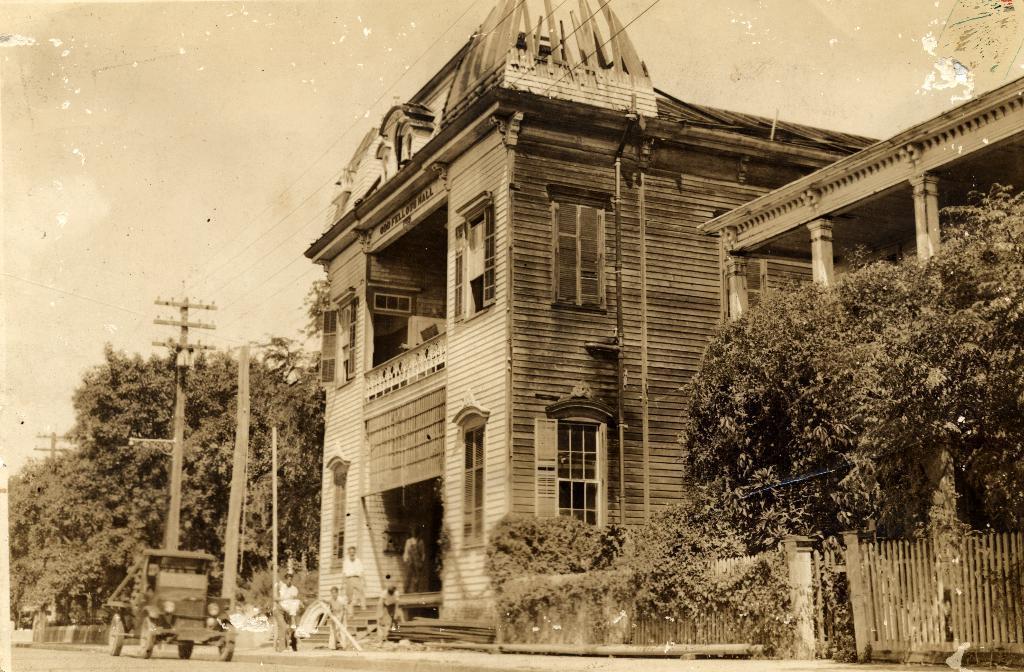Describe this image in one or two sentences. In this image there is the sky towards the top of the image, there are buildings towards the right of the image, there are windows, there is a wall, there are pillars, there is a wooden fence towards the right of the image, there are trees towards the right of the image, there are trees towards the left of the image, there are poles, there are wires towards the top of the image, there are persons standing, there is road towards the bottom of the image, there is a vehicle on the road. 